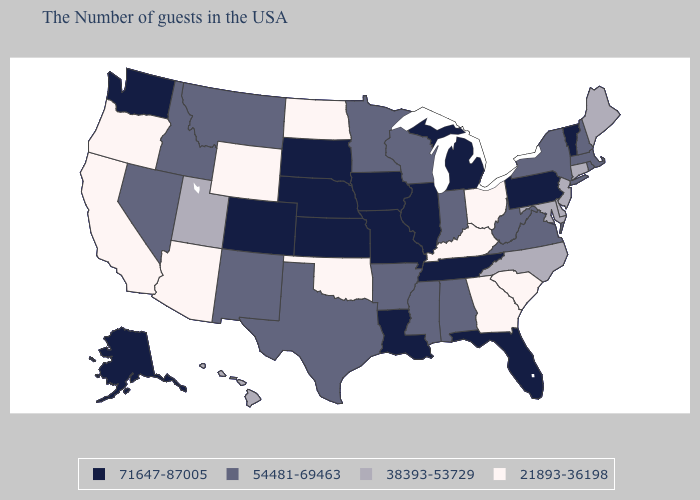Name the states that have a value in the range 21893-36198?
Concise answer only. South Carolina, Ohio, Georgia, Kentucky, Oklahoma, North Dakota, Wyoming, Arizona, California, Oregon. Does Montana have the highest value in the USA?
Keep it brief. No. What is the value of North Dakota?
Answer briefly. 21893-36198. Does Michigan have a higher value than Kentucky?
Keep it brief. Yes. Among the states that border North Dakota , which have the highest value?
Concise answer only. South Dakota. What is the value of New Mexico?
Be succinct. 54481-69463. Does the first symbol in the legend represent the smallest category?
Be succinct. No. Which states have the lowest value in the USA?
Be succinct. South Carolina, Ohio, Georgia, Kentucky, Oklahoma, North Dakota, Wyoming, Arizona, California, Oregon. Does Kentucky have a higher value than Nevada?
Short answer required. No. Name the states that have a value in the range 54481-69463?
Concise answer only. Massachusetts, Rhode Island, New Hampshire, New York, Virginia, West Virginia, Indiana, Alabama, Wisconsin, Mississippi, Arkansas, Minnesota, Texas, New Mexico, Montana, Idaho, Nevada. Does Vermont have the highest value in the Northeast?
Answer briefly. Yes. What is the highest value in the USA?
Keep it brief. 71647-87005. Does Arkansas have the highest value in the USA?
Be succinct. No. What is the lowest value in the USA?
Give a very brief answer. 21893-36198. Does Indiana have the lowest value in the USA?
Short answer required. No. 